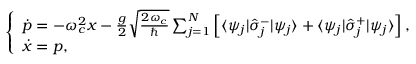<formula> <loc_0><loc_0><loc_500><loc_500>\begin{array} { r } { \left \{ \begin{array} { l l } { \dot { p } = - \omega _ { c } ^ { 2 } x - \frac { g } { 2 } \sqrt { \frac { 2 \omega _ { c } } { } } \sum _ { j = 1 } ^ { N } \left [ \langle \psi _ { j } | \hat { \sigma } _ { j } ^ { - } | \psi _ { j } \rangle + \langle \psi _ { j } | \hat { \sigma } _ { j } ^ { + } | \psi _ { j } \rangle \right ] , } \\ { \dot { x } = p , } \end{array} } \end{array}</formula> 